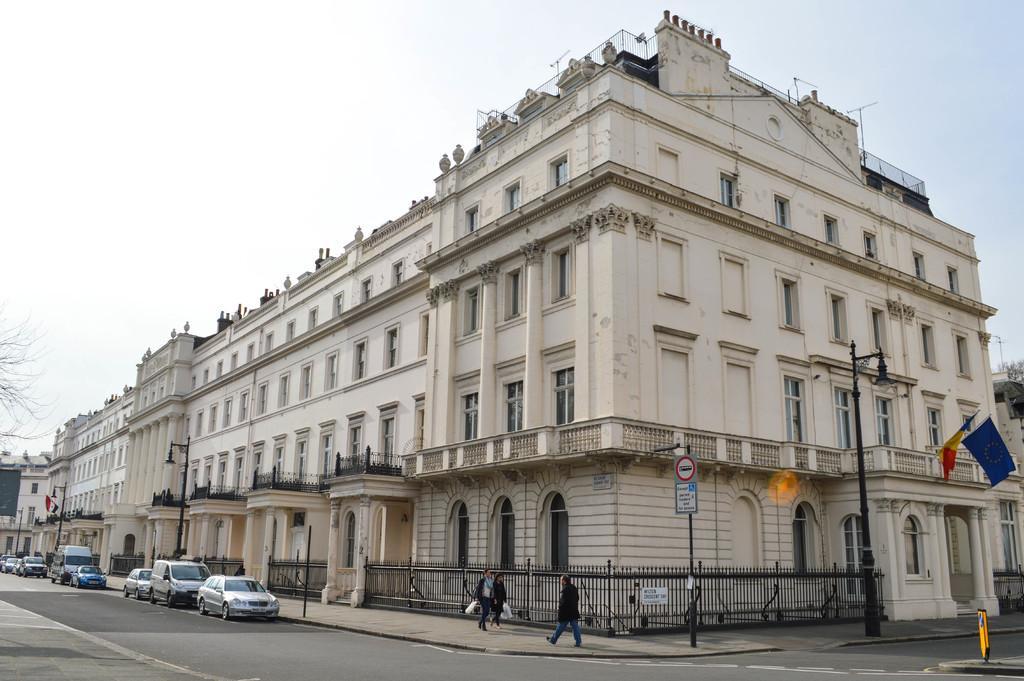Describe this image in one or two sentences. There is a building in the middle. There is sky at the top. There are cars in the bottom left corner. There are some persons walking at the bottom. There are flags on the right side and left side. There are trees on the left side and right side. 